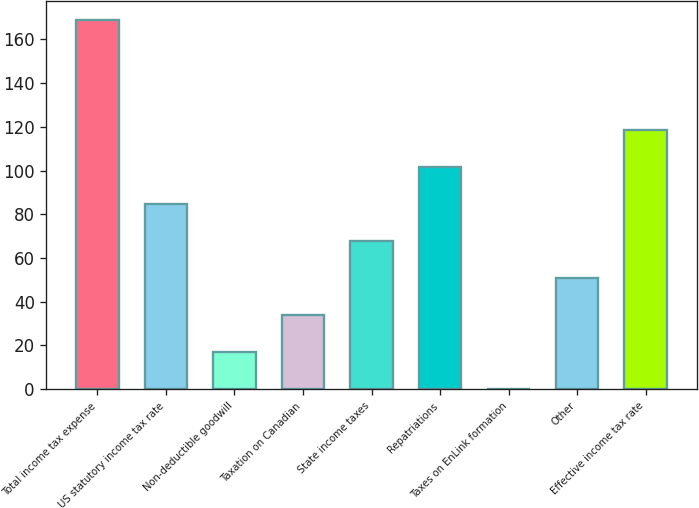Convert chart. <chart><loc_0><loc_0><loc_500><loc_500><bar_chart><fcel>Total income tax expense<fcel>US statutory income tax rate<fcel>Non-deductible goodwill<fcel>Taxation on Canadian<fcel>State income taxes<fcel>Repatriations<fcel>Taxes on EnLink formation<fcel>Other<fcel>Effective income tax rate<nl><fcel>169<fcel>84.61<fcel>17.13<fcel>34<fcel>67.74<fcel>101.48<fcel>0.26<fcel>50.87<fcel>118.35<nl></chart> 